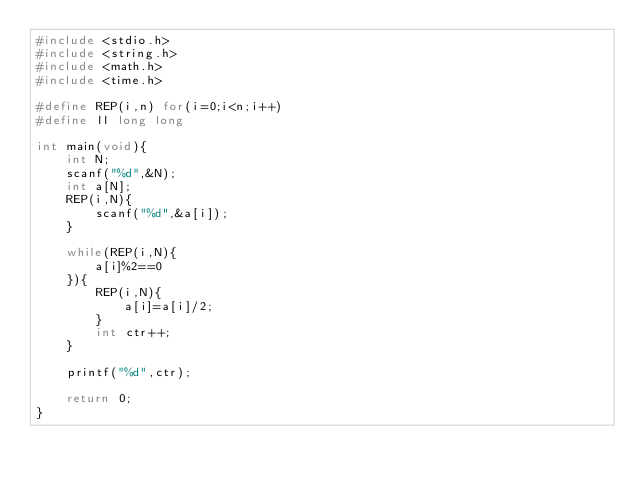<code> <loc_0><loc_0><loc_500><loc_500><_C_>#include <stdio.h>
#include <string.h>
#include <math.h>
#include <time.h>

#define REP(i,n) for(i=0;i<n;i++)
#define ll long long

int main(void){
    int N;
    scanf("%d",&N);
    int a[N];
    REP(i,N){
        scanf("%d",&a[i]);
    }

    while(REP(i,N){
        a[i]%2==0
    }){
        REP(i,N){
            a[i]=a[i]/2;
        }
        int ctr++;
    }

    printf("%d",ctr);
    
    return 0;
}</code> 